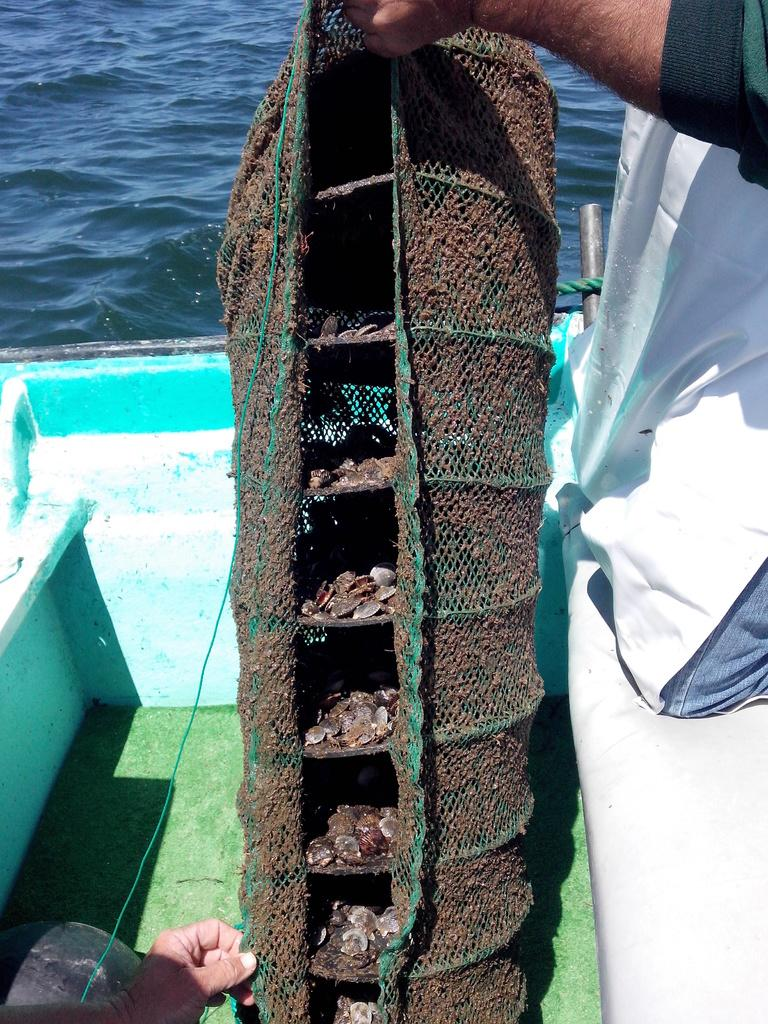What is the main subject of the image? The main subject of the image is a hand holding a shells container. Are there any other hands visible in the image? Yes, there is another hand in the bottom left of the image. What can be seen in the top of the image? There is water visible at the top of the image. How many stars can be seen in the image? There are no stars visible in the image. What type of nut is being cracked by the hand in the bottom left of the image? There is no nut being cracked in the image; only a hand is visible in the bottom left. 